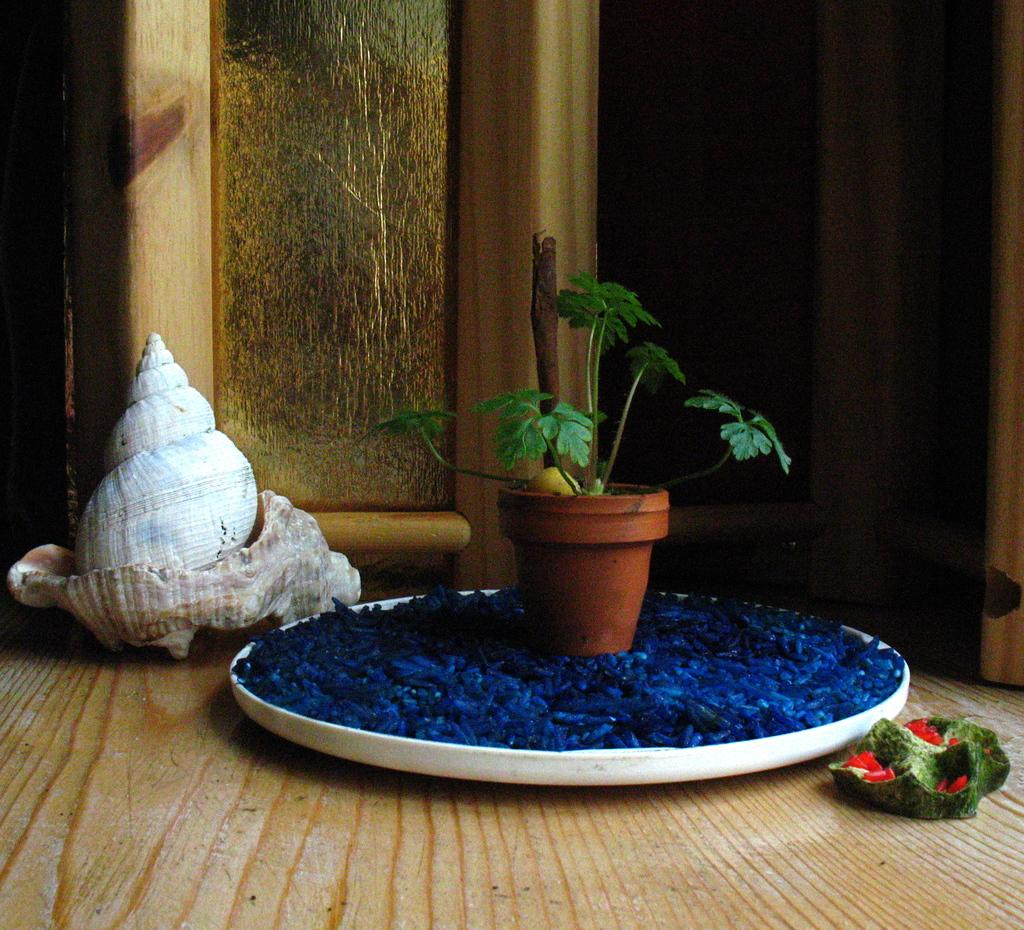What type of plant can be seen in the image? There is a house plant in the image. Where is the house plant placed? The house plant is on a decorative item. What colors are the objects on the floor? There is a green object and a red object on the floor. What can be seen in the background of the image? There is a seashell and wooden objects in the background of the image. What type of teaching is happening in the image? There is no teaching happening in the image; it features a house plant, decorative items, and objects on the floor. How many family members are present in the image? There is no family present in the image; it features a house plant, decorative items, and objects on the floor. 